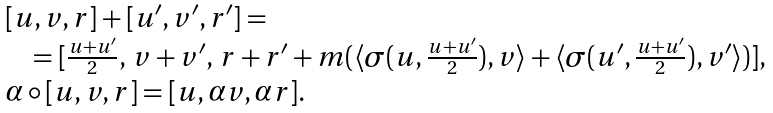<formula> <loc_0><loc_0><loc_500><loc_500>\begin{array} { l } [ u , v , r ] + [ u ^ { \prime } , v ^ { \prime } , r ^ { \prime } ] = \\ \quad = [ \frac { u + u ^ { \prime } } { 2 } , \, v + v ^ { \prime } , \, r + r ^ { \prime } + m ( \langle \sigma ( u , \frac { u + u ^ { \prime } } { 2 } ) , v \rangle + \langle \sigma ( u ^ { \prime } , \frac { u + u ^ { \prime } } { 2 } ) , v ^ { \prime } \rangle ) ] , \\ \alpha \circ [ u , v , r ] = [ u , \alpha v , \alpha r ] . \end{array}</formula> 